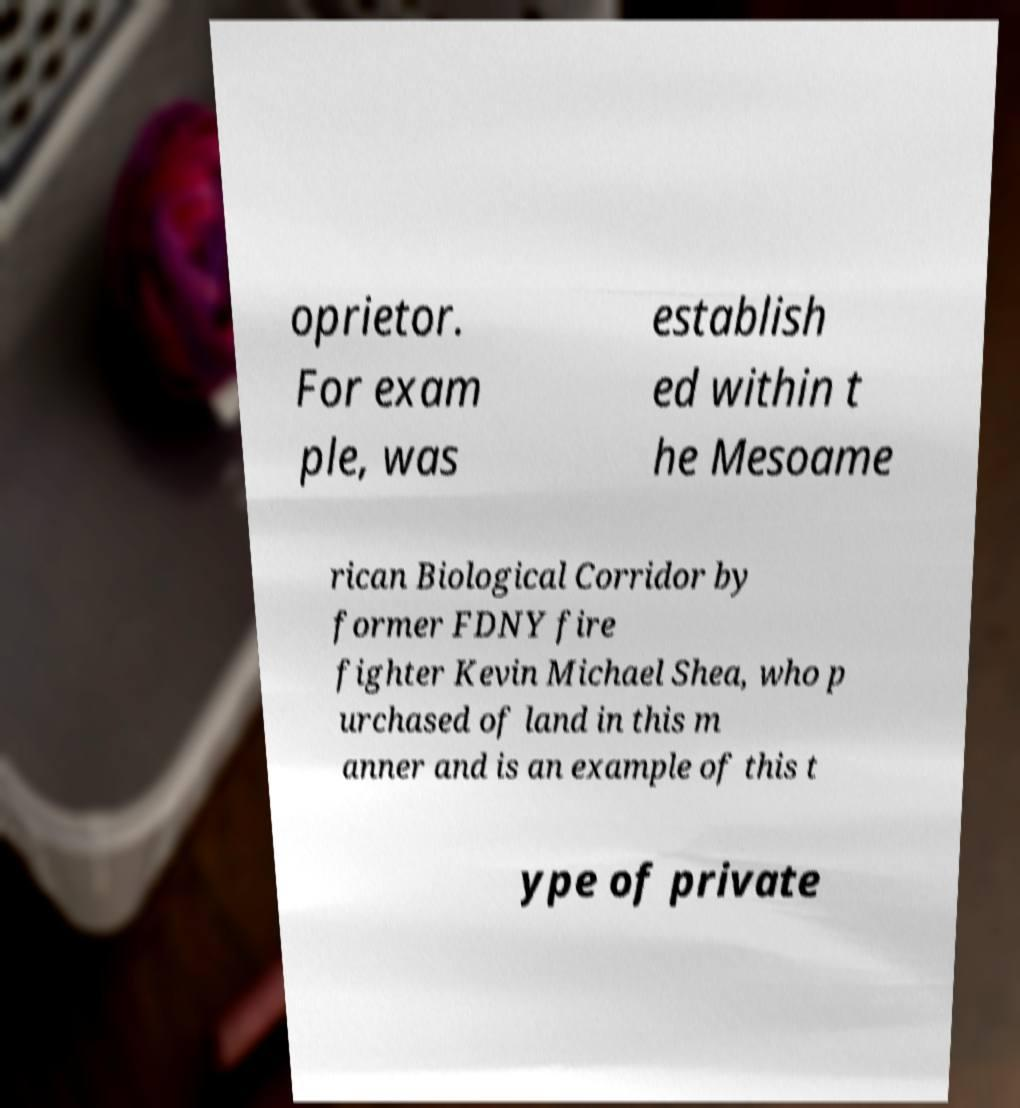Can you accurately transcribe the text from the provided image for me? oprietor. For exam ple, was establish ed within t he Mesoame rican Biological Corridor by former FDNY fire fighter Kevin Michael Shea, who p urchased of land in this m anner and is an example of this t ype of private 